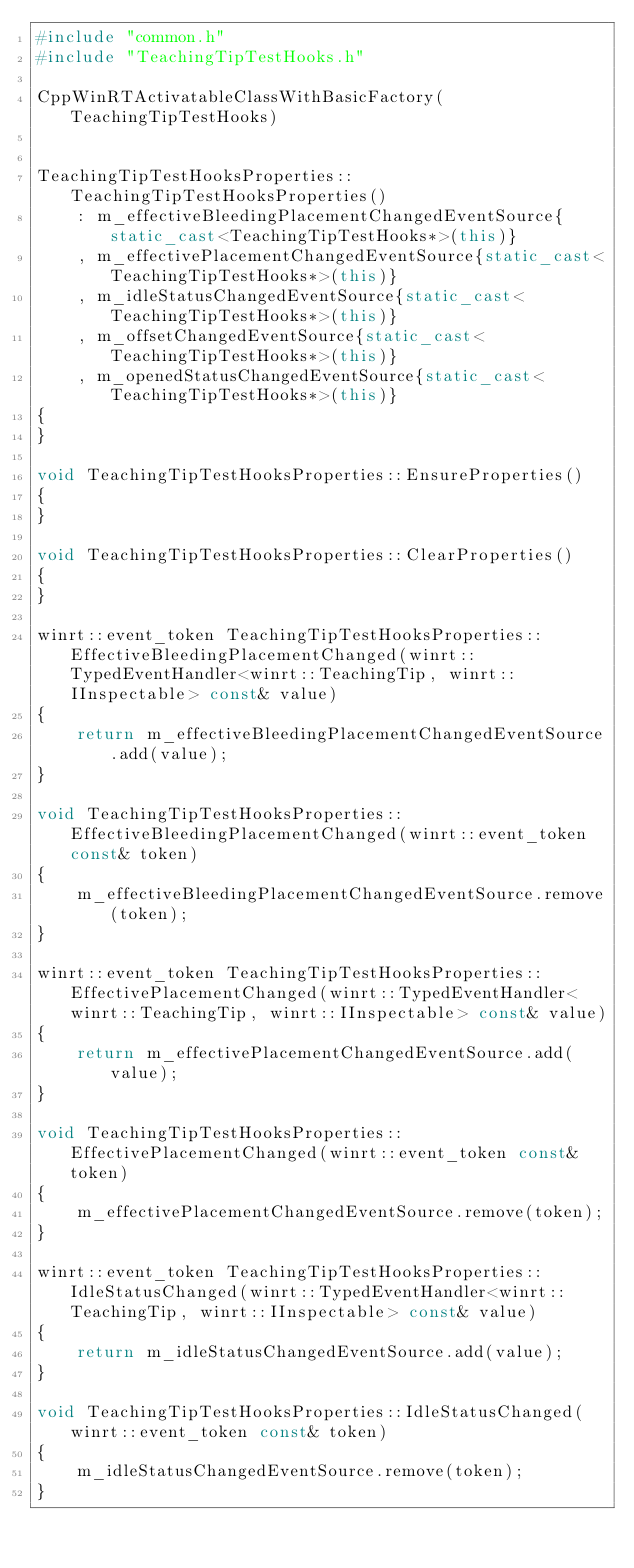Convert code to text. <code><loc_0><loc_0><loc_500><loc_500><_C++_>#include "common.h"
#include "TeachingTipTestHooks.h"

CppWinRTActivatableClassWithBasicFactory(TeachingTipTestHooks)


TeachingTipTestHooksProperties::TeachingTipTestHooksProperties()
    : m_effectiveBleedingPlacementChangedEventSource{static_cast<TeachingTipTestHooks*>(this)}
    , m_effectivePlacementChangedEventSource{static_cast<TeachingTipTestHooks*>(this)}
    , m_idleStatusChangedEventSource{static_cast<TeachingTipTestHooks*>(this)}
    , m_offsetChangedEventSource{static_cast<TeachingTipTestHooks*>(this)}
    , m_openedStatusChangedEventSource{static_cast<TeachingTipTestHooks*>(this)}
{
}

void TeachingTipTestHooksProperties::EnsureProperties()
{
}

void TeachingTipTestHooksProperties::ClearProperties()
{
}

winrt::event_token TeachingTipTestHooksProperties::EffectiveBleedingPlacementChanged(winrt::TypedEventHandler<winrt::TeachingTip, winrt::IInspectable> const& value)
{
    return m_effectiveBleedingPlacementChangedEventSource.add(value);
}

void TeachingTipTestHooksProperties::EffectiveBleedingPlacementChanged(winrt::event_token const& token)
{
    m_effectiveBleedingPlacementChangedEventSource.remove(token);
}

winrt::event_token TeachingTipTestHooksProperties::EffectivePlacementChanged(winrt::TypedEventHandler<winrt::TeachingTip, winrt::IInspectable> const& value)
{
    return m_effectivePlacementChangedEventSource.add(value);
}

void TeachingTipTestHooksProperties::EffectivePlacementChanged(winrt::event_token const& token)
{
    m_effectivePlacementChangedEventSource.remove(token);
}

winrt::event_token TeachingTipTestHooksProperties::IdleStatusChanged(winrt::TypedEventHandler<winrt::TeachingTip, winrt::IInspectable> const& value)
{
    return m_idleStatusChangedEventSource.add(value);
}

void TeachingTipTestHooksProperties::IdleStatusChanged(winrt::event_token const& token)
{
    m_idleStatusChangedEventSource.remove(token);
}
</code> 